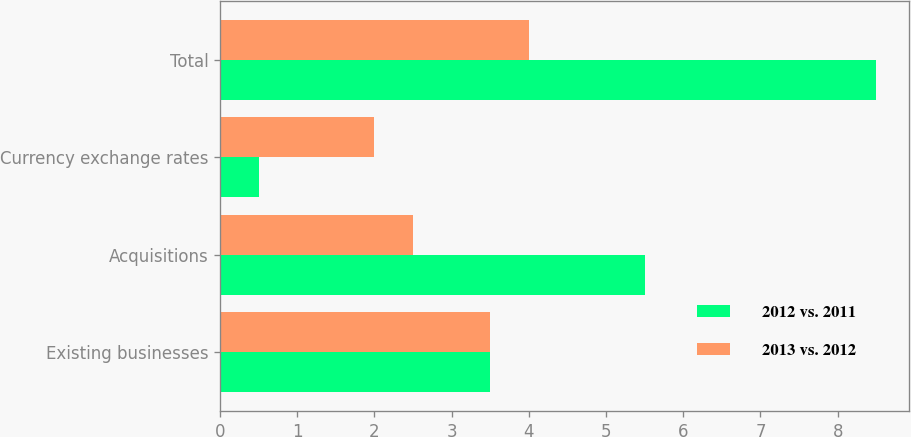Convert chart. <chart><loc_0><loc_0><loc_500><loc_500><stacked_bar_chart><ecel><fcel>Existing businesses<fcel>Acquisitions<fcel>Currency exchange rates<fcel>Total<nl><fcel>2012 vs. 2011<fcel>3.5<fcel>5.5<fcel>0.5<fcel>8.5<nl><fcel>2013 vs. 2012<fcel>3.5<fcel>2.5<fcel>2<fcel>4<nl></chart> 